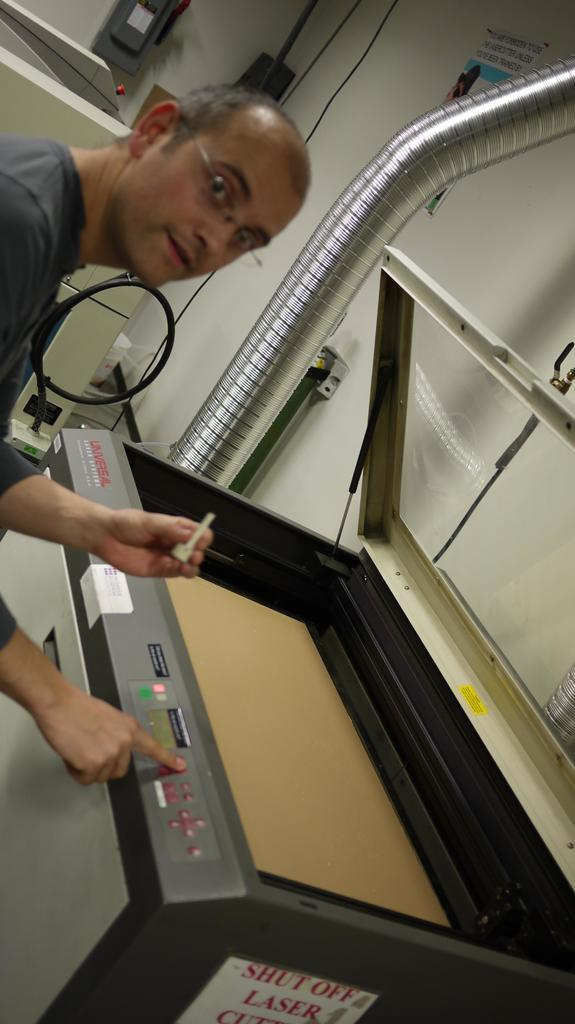What is the person in the image doing? The person in the image is operating a machine. What can be seen connected to the machine? There are pipes visible in the image. What is the background of the image? There is a wall in the image. What note is the person playing on the son's page in the image? There is no musical instrument, note, or page present in the image. 